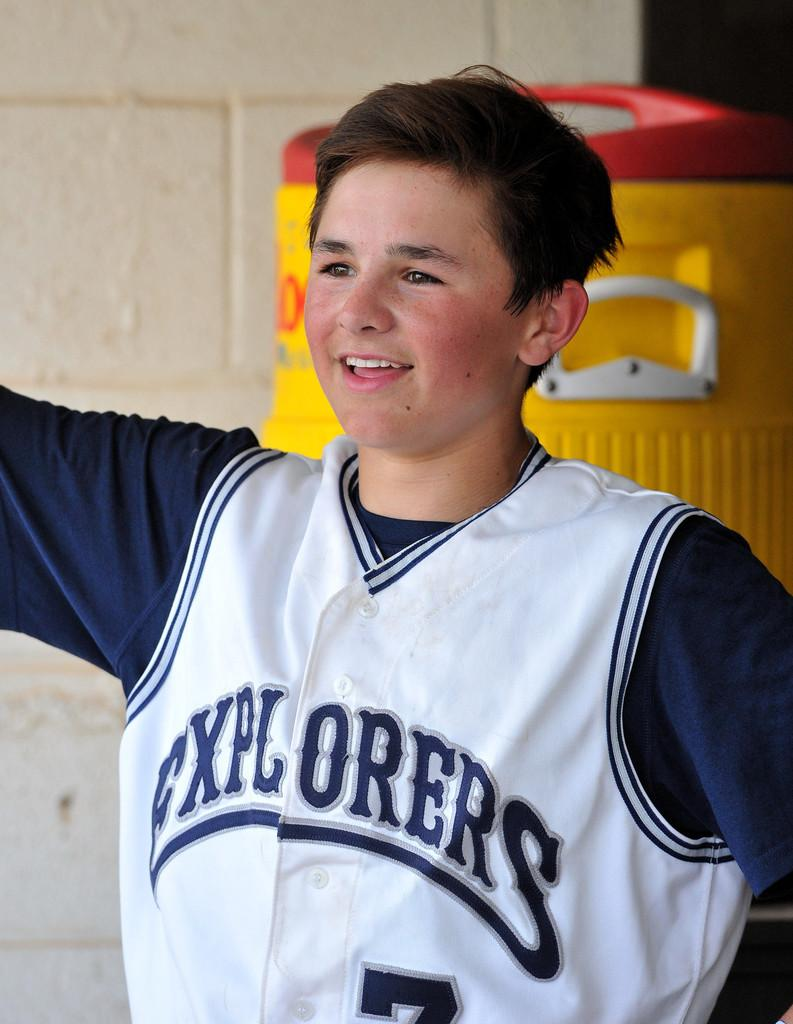Provide a one-sentence caption for the provided image. The jersey that the kid is wearing is for the team the Explorers. 